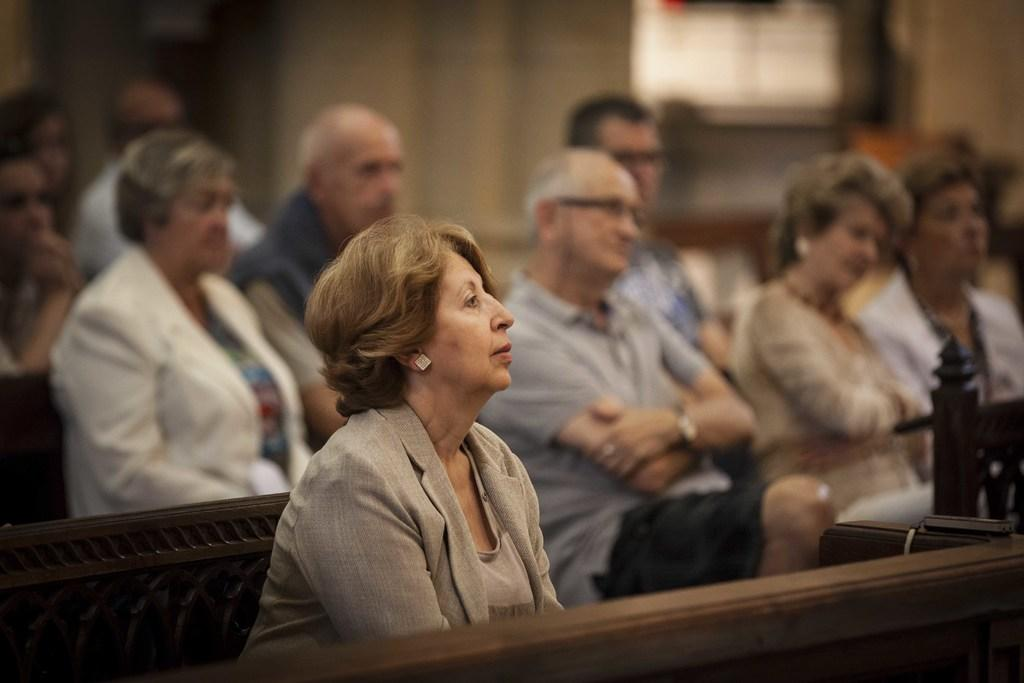What are the people in the image doing? The people in the image are sitting on benches. Can you describe the background of the image? The background of the image is blurred. What type of hope can be seen in the image? There is no hope present in the image; it features people sitting on benches with a blurred background. 